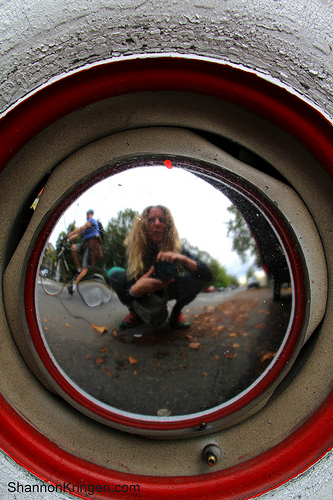<image>
Can you confirm if the lady is in the mirror? Yes. The lady is contained within or inside the mirror, showing a containment relationship. 